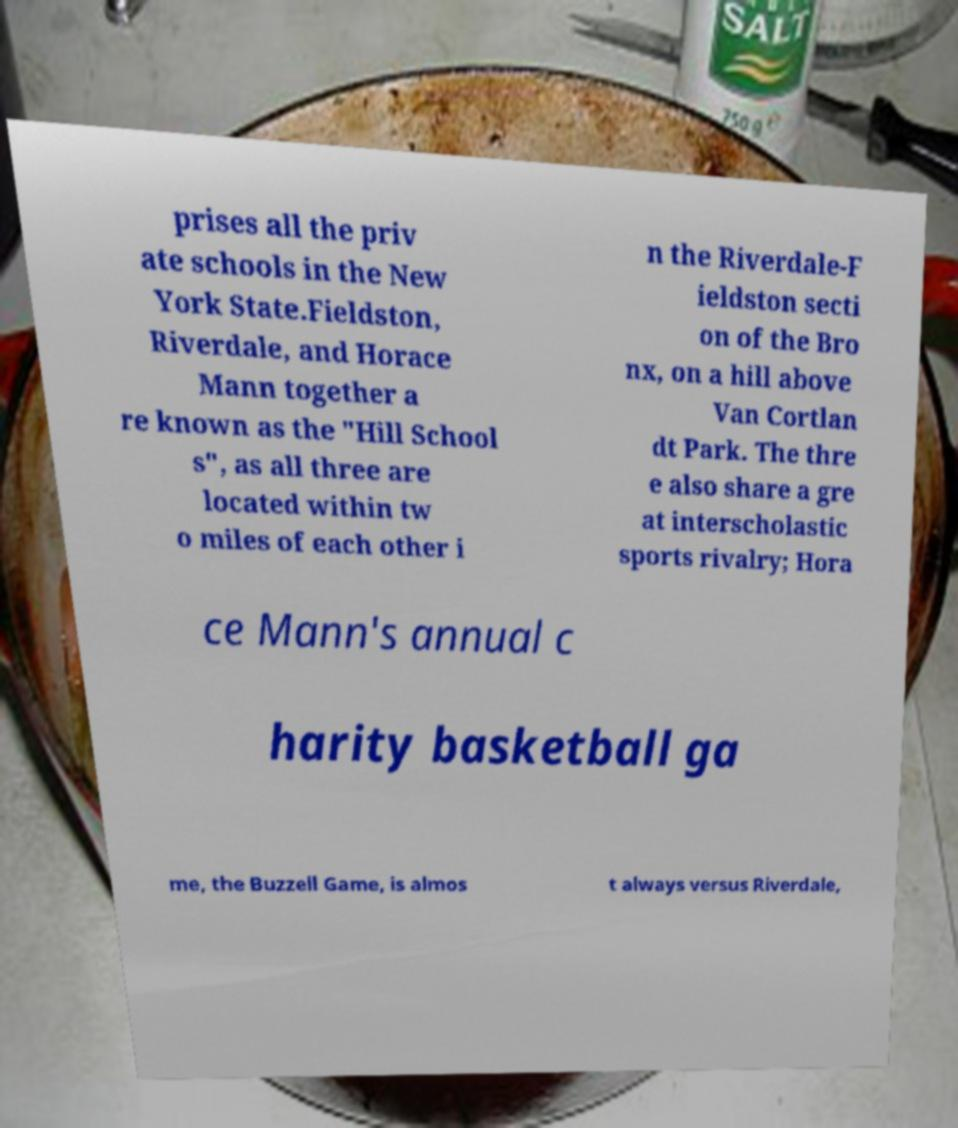For documentation purposes, I need the text within this image transcribed. Could you provide that? prises all the priv ate schools in the New York State.Fieldston, Riverdale, and Horace Mann together a re known as the "Hill School s", as all three are located within tw o miles of each other i n the Riverdale-F ieldston secti on of the Bro nx, on a hill above Van Cortlan dt Park. The thre e also share a gre at interscholastic sports rivalry; Hora ce Mann's annual c harity basketball ga me, the Buzzell Game, is almos t always versus Riverdale, 